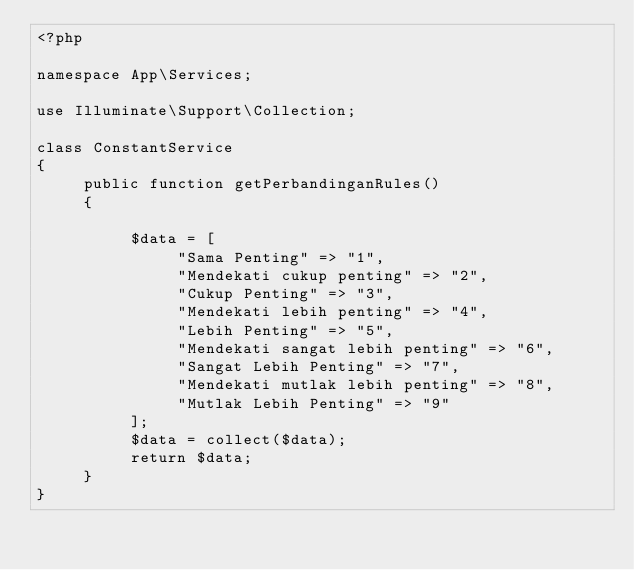Convert code to text. <code><loc_0><loc_0><loc_500><loc_500><_PHP_><?php

namespace App\Services;

use Illuminate\Support\Collection;

class ConstantService
{
     public function getPerbandinganRules()
     {

          $data = [
               "Sama Penting" => "1",
               "Mendekati cukup penting" => "2",
               "Cukup Penting" => "3",
               "Mendekati lebih penting" => "4",
               "Lebih Penting" => "5",
               "Mendekati sangat lebih penting" => "6",
               "Sangat Lebih Penting" => "7",
               "Mendekati mutlak lebih penting" => "8",
               "Mutlak Lebih Penting" => "9"
          ];
          $data = collect($data);
          return $data;
     }
}
</code> 